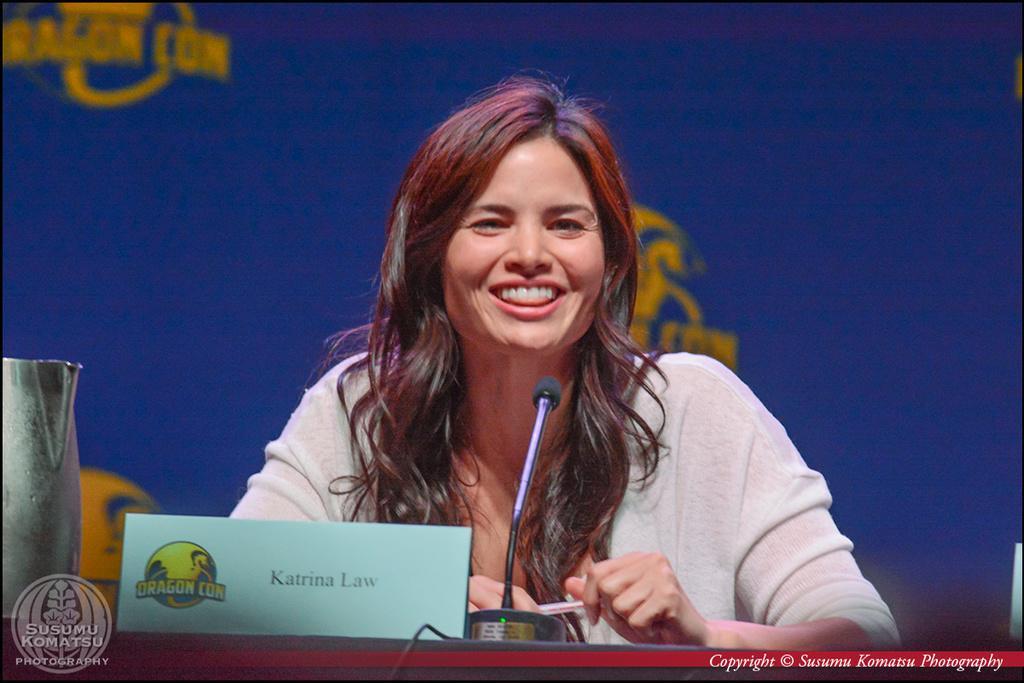Can you describe this image briefly? In this image I can see the person is wearing white color dress and smiling. In front I can see the mic, board and few objects. Background is in blue and yellow color. 